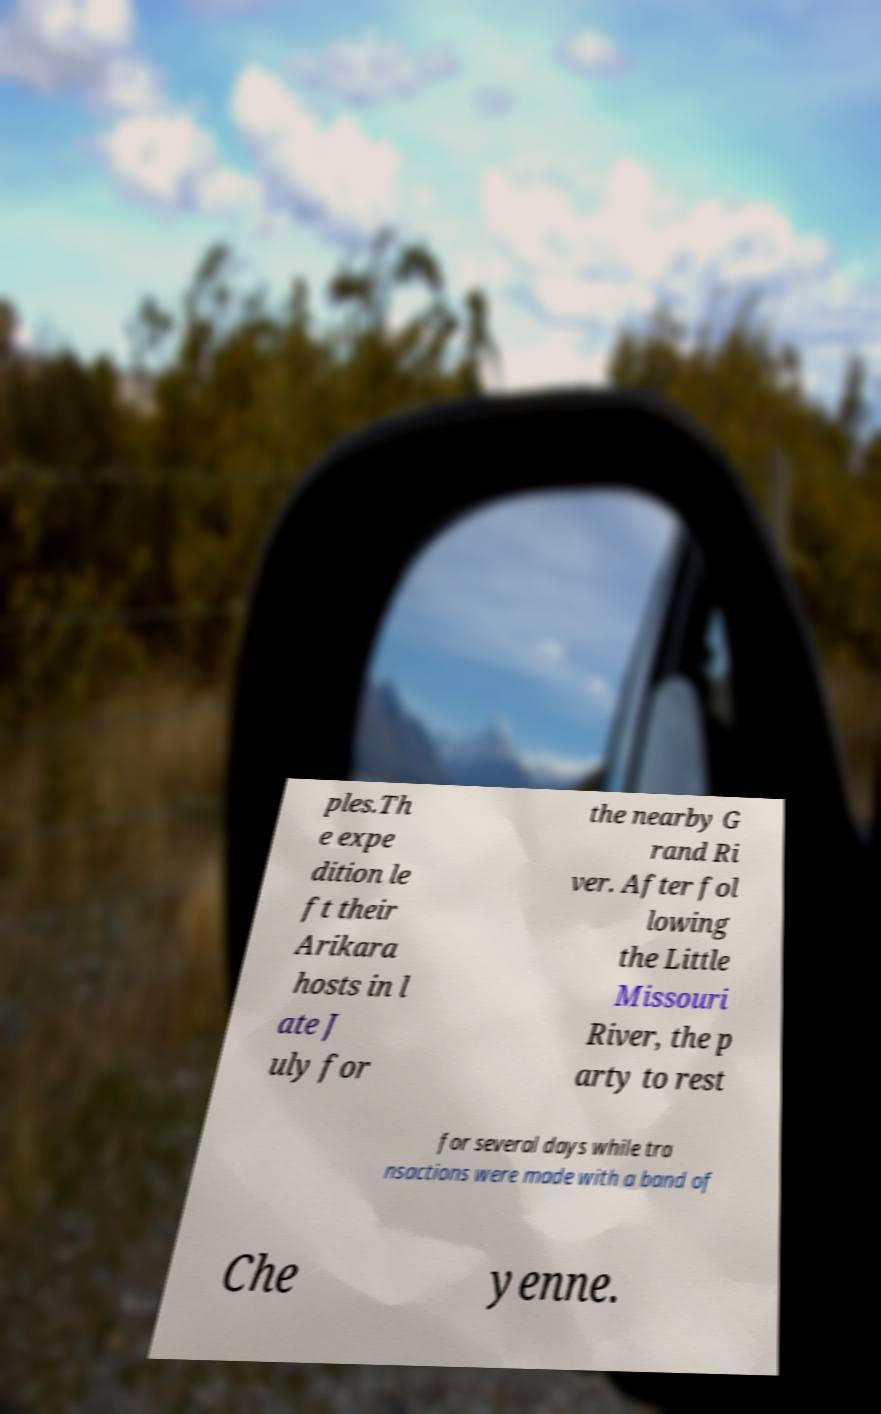I need the written content from this picture converted into text. Can you do that? ples.Th e expe dition le ft their Arikara hosts in l ate J uly for the nearby G rand Ri ver. After fol lowing the Little Missouri River, the p arty to rest for several days while tra nsactions were made with a band of Che yenne. 